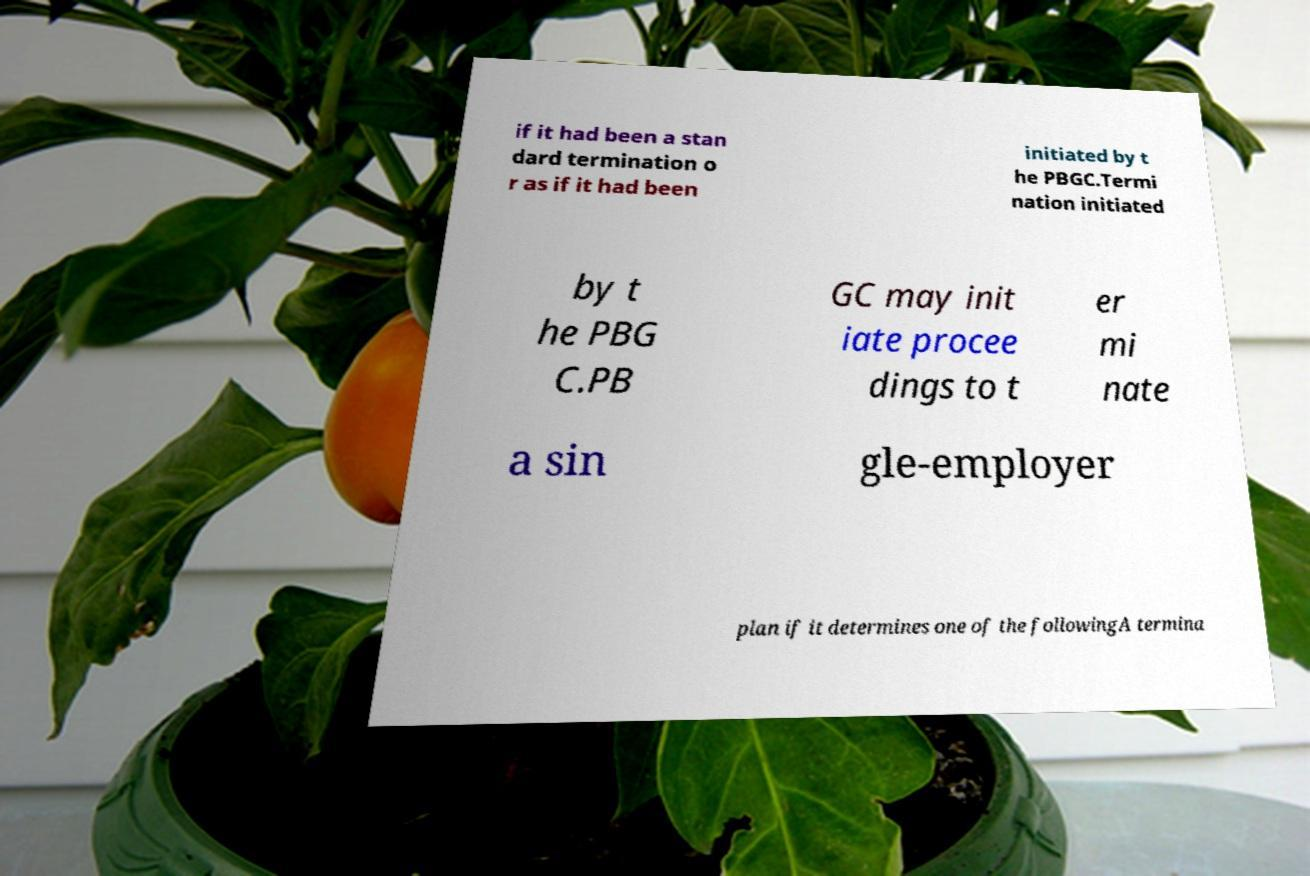For documentation purposes, I need the text within this image transcribed. Could you provide that? if it had been a stan dard termination o r as if it had been initiated by t he PBGC.Termi nation initiated by t he PBG C.PB GC may init iate procee dings to t er mi nate a sin gle-employer plan if it determines one of the followingA termina 